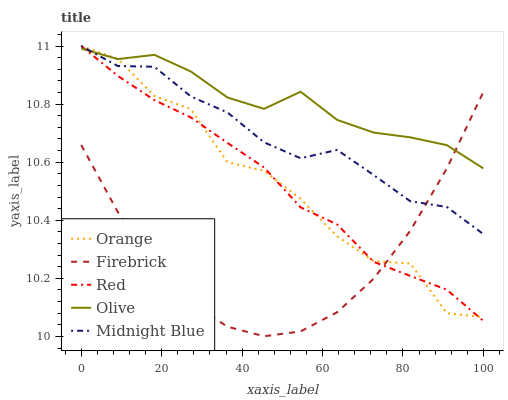Does Firebrick have the minimum area under the curve?
Answer yes or no. Yes. Does Olive have the maximum area under the curve?
Answer yes or no. Yes. Does Olive have the minimum area under the curve?
Answer yes or no. No. Does Firebrick have the maximum area under the curve?
Answer yes or no. No. Is Red the smoothest?
Answer yes or no. Yes. Is Orange the roughest?
Answer yes or no. Yes. Is Olive the smoothest?
Answer yes or no. No. Is Olive the roughest?
Answer yes or no. No. Does Firebrick have the lowest value?
Answer yes or no. Yes. Does Olive have the lowest value?
Answer yes or no. No. Does Red have the highest value?
Answer yes or no. Yes. Does Olive have the highest value?
Answer yes or no. No. Does Midnight Blue intersect Orange?
Answer yes or no. Yes. Is Midnight Blue less than Orange?
Answer yes or no. No. Is Midnight Blue greater than Orange?
Answer yes or no. No. 